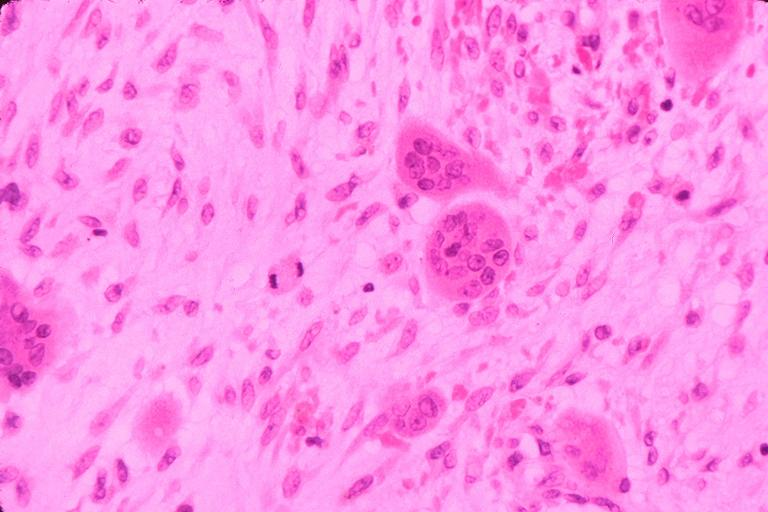where is this?
Answer the question using a single word or phrase. Oral 